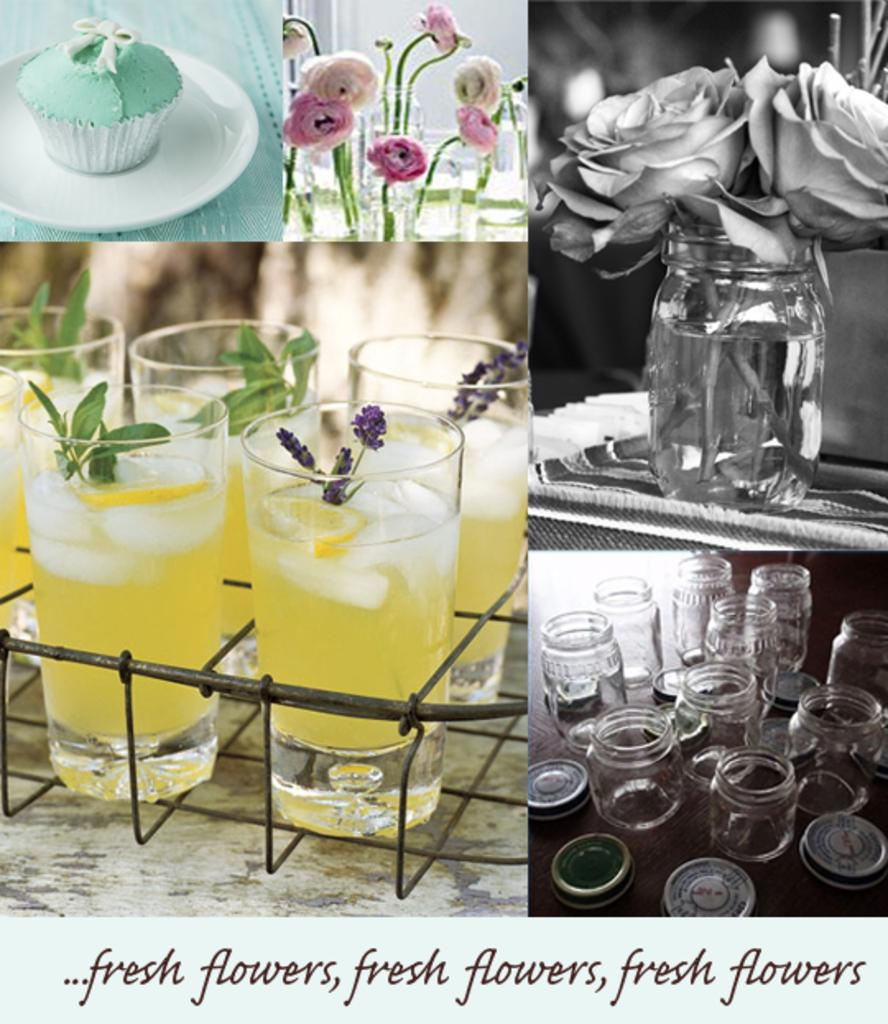What type of artwork is the image? The image is a collage. What type of food can be seen in the image? There is a cupcake in the image. What type of plants are in the image? There are different flowers in the image. What is used to hold the flowers in the image? There is a flower vase in the image. What type of containers are in the image? There are containers in the image. What type of beverage is in the glasses in the image? There are drinking glasses with juice in the image. How many spiders are crawling on the cupcake in the image? There are no spiders present in the image; it only features a cupcake, flowers, a flower vase, containers, and drinking glasses with juice. Can you see steam coming from the flowers in the image? There is no steam present in the image; it only features a cupcake, flowers, a flower vase, containers, and drinking glasses with juice. 